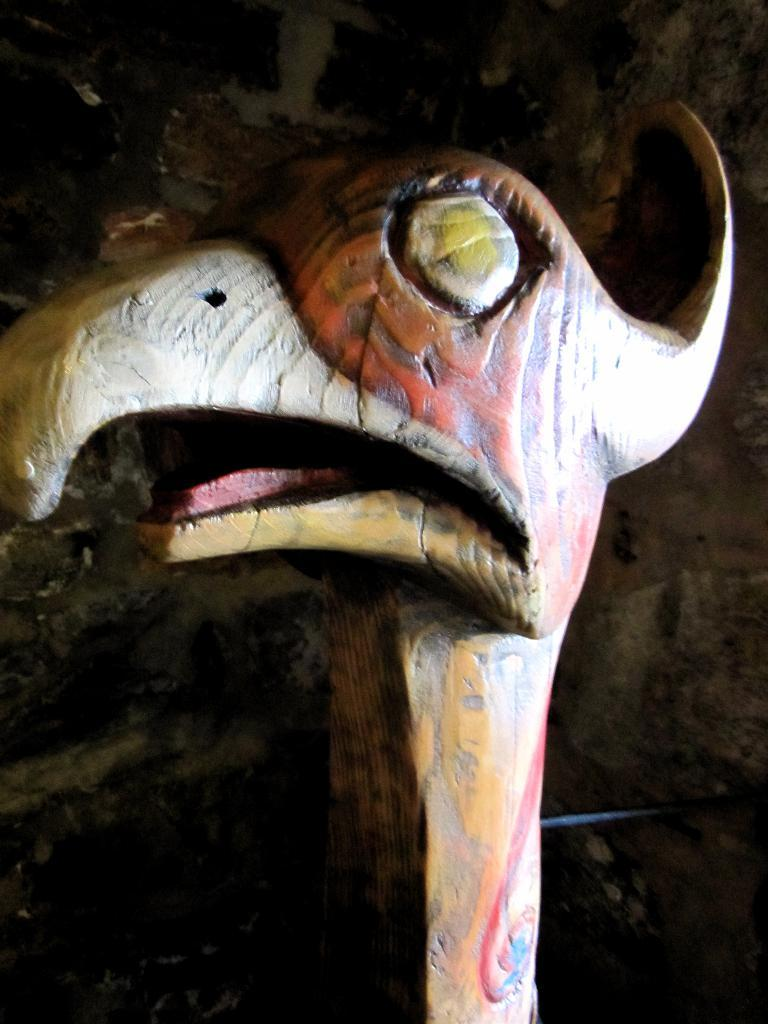What is the main subject in the image? There is a statue in the image. What material is the statue made of? The statue is made of wood. What type of cloth is draped over the oven in the image? There is no oven or cloth present in the image; it only features a wooden statue. 